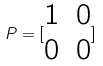<formula> <loc_0><loc_0><loc_500><loc_500>P = [ \begin{matrix} 1 & 0 \\ 0 & 0 \end{matrix} ]</formula> 